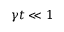<formula> <loc_0><loc_0><loc_500><loc_500>\gamma t \ll 1</formula> 